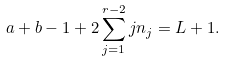Convert formula to latex. <formula><loc_0><loc_0><loc_500><loc_500>a + b - 1 + 2 \sum _ { j = 1 } ^ { r - 2 } j n _ { j } = L + 1 .</formula> 